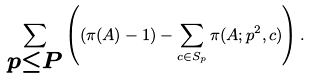<formula> <loc_0><loc_0><loc_500><loc_500>\sum _ { \substack { p \leq P } } \left ( ( \pi ( A ) - 1 ) - \sum _ { c \in S _ { p } } \pi ( A ; p ^ { 2 } , c ) \right ) .</formula> 